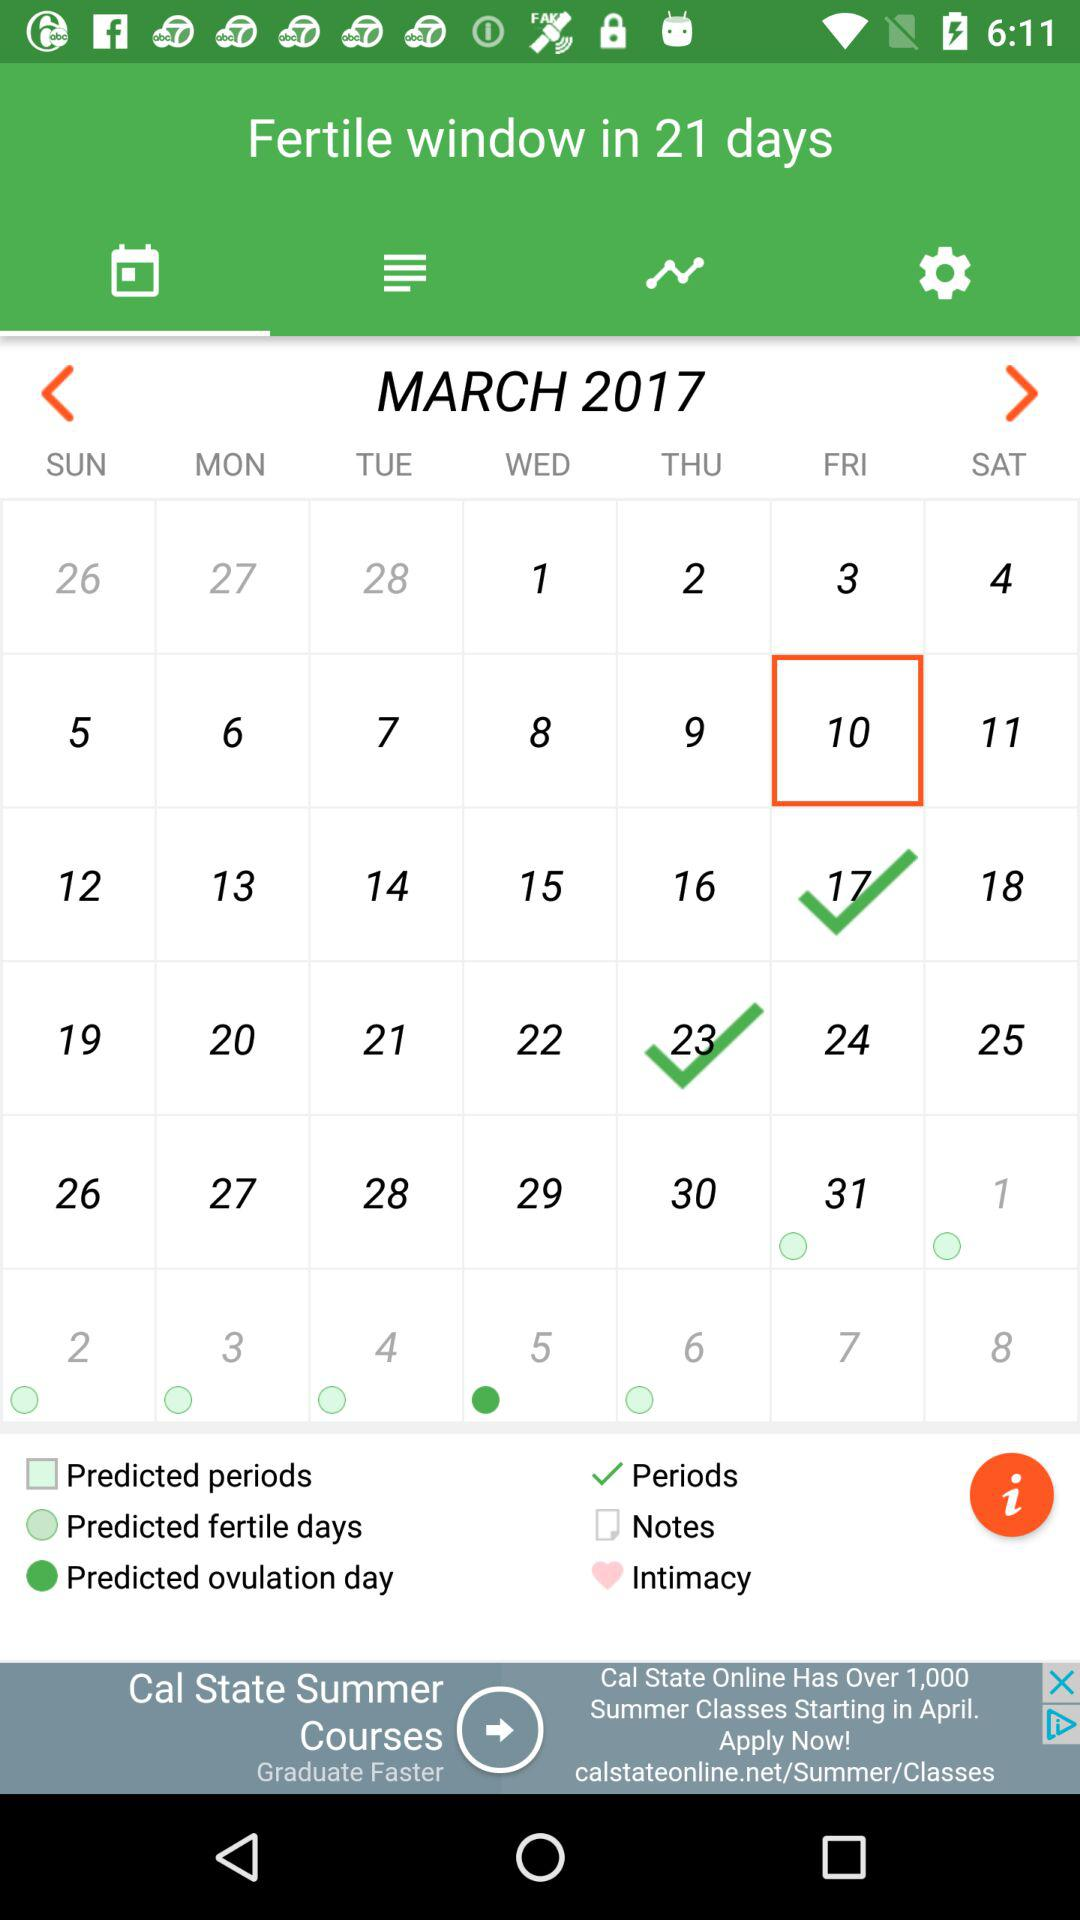How many dates are in the month of March?
Answer the question using a single word or phrase. 31 